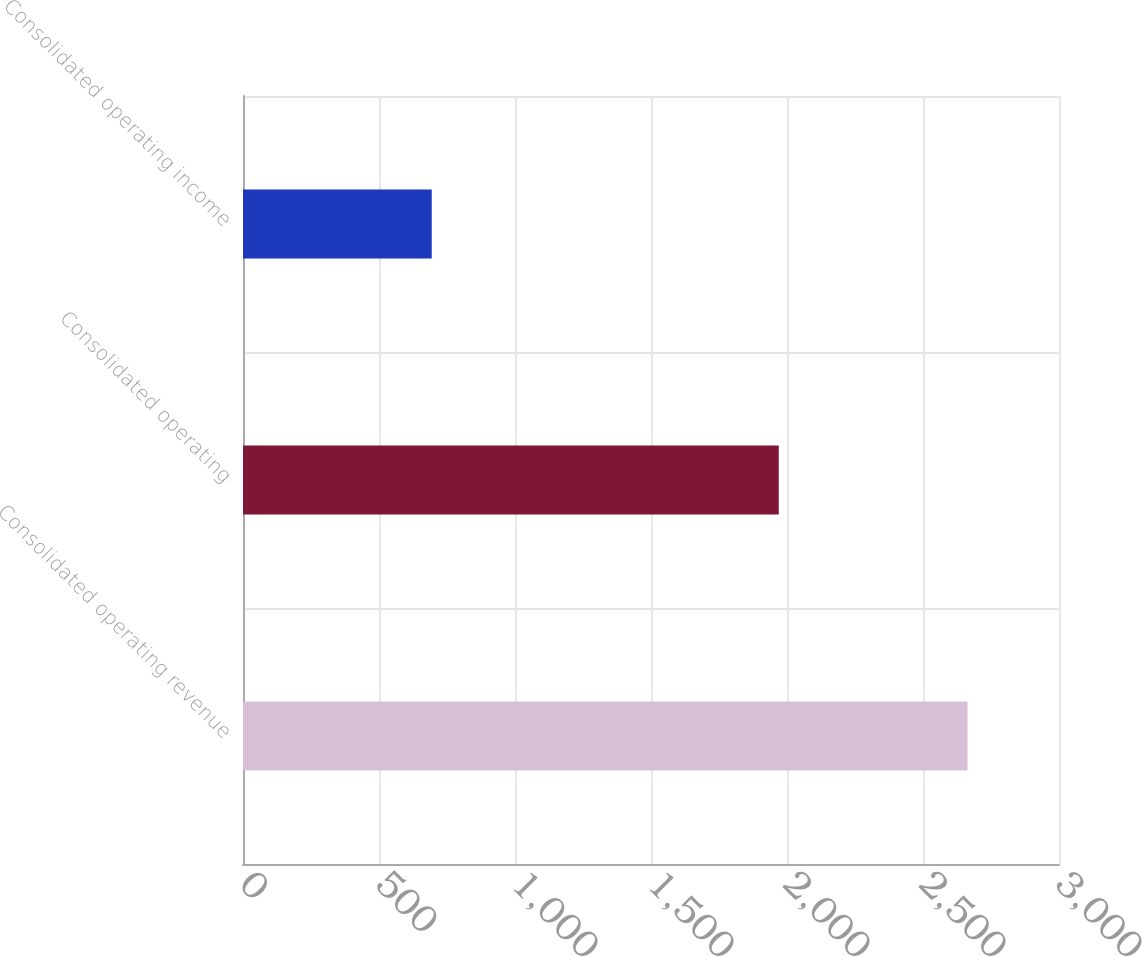Convert chart to OTSL. <chart><loc_0><loc_0><loc_500><loc_500><bar_chart><fcel>Consolidated operating revenue<fcel>Consolidated operating<fcel>Consolidated operating income<nl><fcel>2663.6<fcel>1969.7<fcel>693.9<nl></chart> 